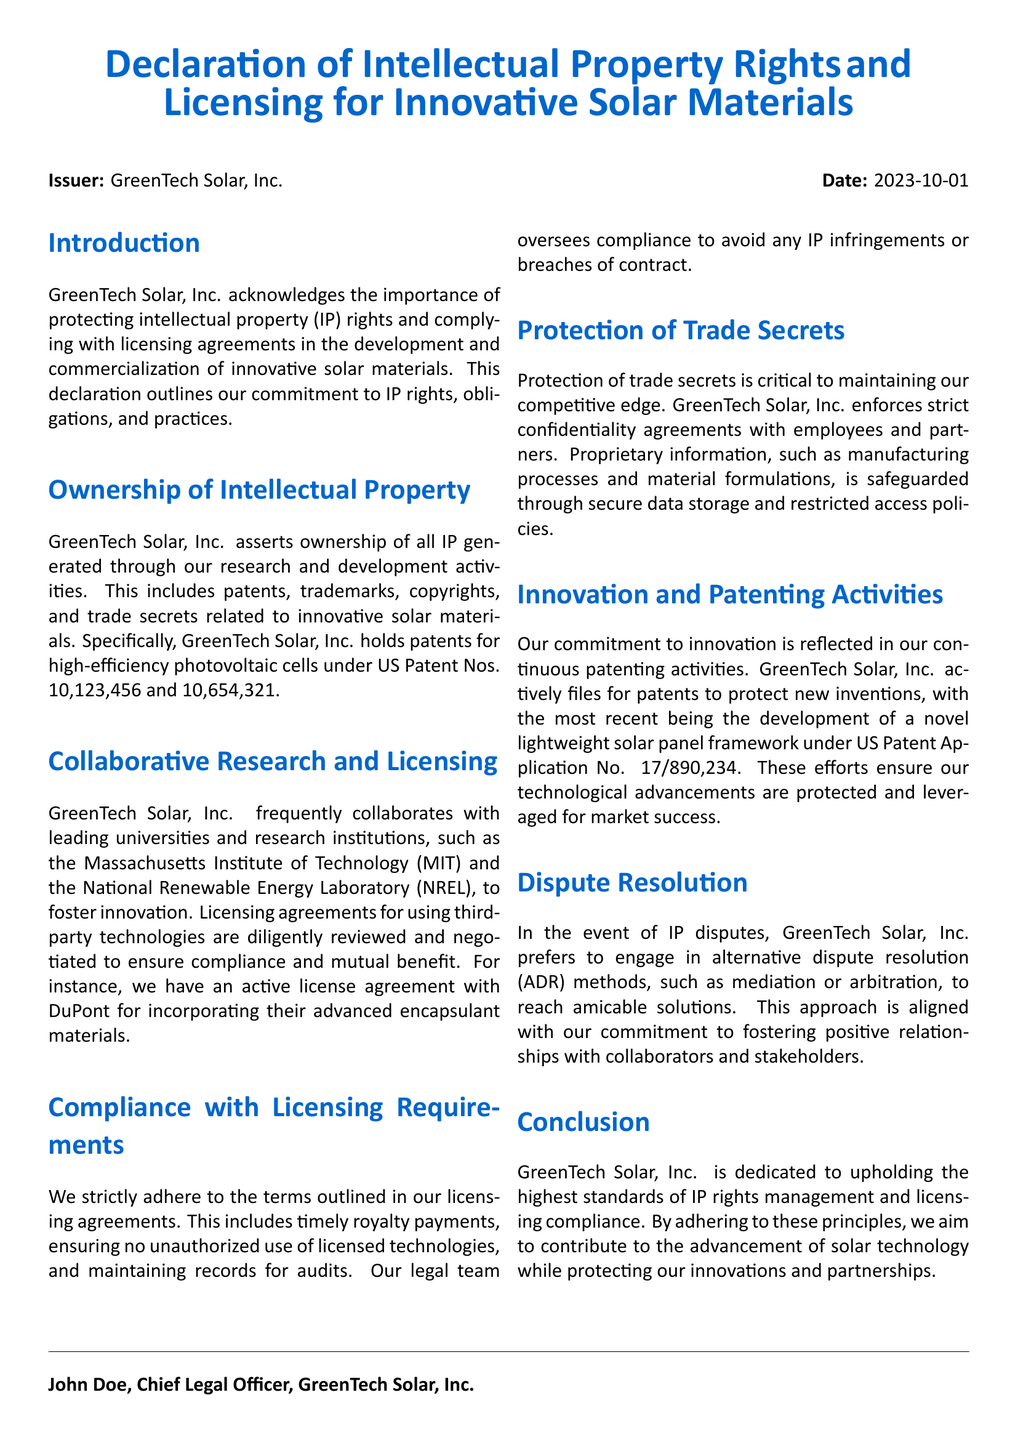what is the issuer of the document? The issuer is the entity that created the declaration, which is stated in the document.
Answer: GreenTech Solar, Inc what is the date of the declaration? The date is provided in the document as a specific reference for when the declaration was issued.
Answer: 2023-10-01 which patents are mentioned in the document? The document specifies patents held by GreenTech Solar, Inc. in relation to their innovations.
Answer: US Patent Nos. 10,123,456 and 10,654,321 what is the name of the Chief Legal Officer? The document includes the name of the individual who signed the declaration, which establishes authority.
Answer: John Doe who is mentioned as a collaboration partner for research? This question seeks the name of an institution that collaborates with GreenTech Solar, Inc., as stated in the text.
Answer: Massachusetts Institute of Technology (MIT) what is the active license agreement mentioned in the document? The document lists a specific licensing agreement, which highlights GreenTech's partnerships related to their materials.
Answer: DuPont which method does GreenTech Solar prefer for dispute resolution? The document describes the preferred approach for handling disputes, indicating their stance on conflict management.
Answer: alternative dispute resolution (ADR) what is emphasized as critical for maintaining a competitive edge? The document reflects the importance of a particular practice to ensure business advantage in the industry.
Answer: Protection of trade secrets what recent patent application is noted in the declaration? The document identifies a particular patent application, illustrating the company's commitment to innovation.
Answer: US Patent Application No. 17/890,234 